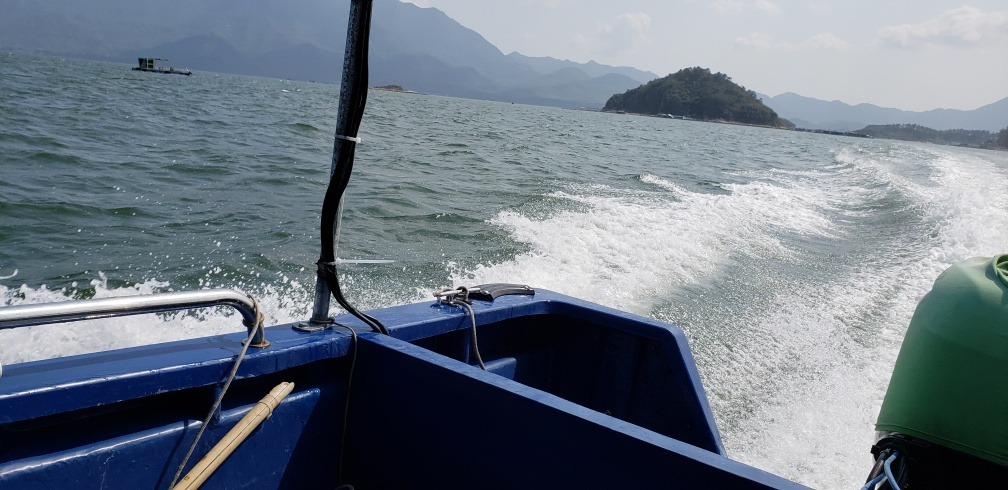What can you infer about the weather conditions in this image? The weather in the image appears to be fair, with sufficient sunlight suggesting it's a bright day. However, there is a slight haze, which might hint at humidity or a mildly overcast sky, typical of coastal or lakeside regions. There are no strong indicators of inclement weather at the time the image was captured. 